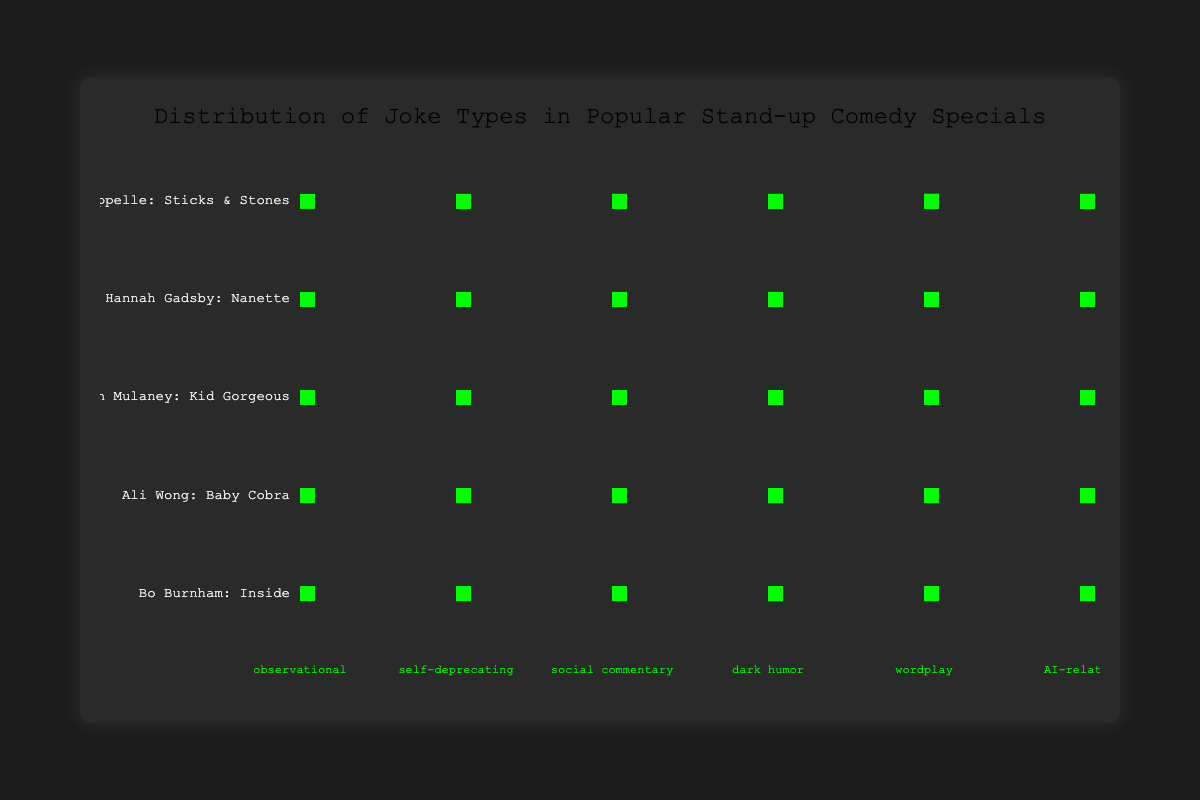What is the title of the chart? The title of the chart is usually placed at the top and in larger, more prominent text compared to other labels. In this figure, the title is "Distribution of Joke Types in Popular Stand-up Comedy Specials."
Answer: Distribution of Joke Types in Popular Stand-up Comedy Specials How many comedians' specials are represented in the chart? There are labels on the left side of the chart indicating the comedians' specials. By counting these labels, you can determine that there are 5 comedians' specials in the chart: "Dave Chappelle: Sticks & Stones," "Hannah Gadsby: Nanette," "John Mulaney: Kid Gorgeous," "Ali Wong: Baby Cobra," and "Bo Burnham: Inside."
Answer: 5 Which comedian has the most jokes categorized under observational humor? By looking at the jokes categorized under "observational" and comparing the depicted count for each comedian, you observe that "John Mulaney: Kid Gorgeous" has the most jokes in the observational humor category, as its bar is the longest.
Answer: John Mulaney: Kid Gorgeous How many total jokes are represented for "Ali Wong: Baby Cobra"? For "Ali Wong: Baby Cobra," you sum the number of jokes in each category: 30 (observational) + 20 (self-deprecating) + 25 (social commentary) + 10 (dark humor) + 10 (wordplay) + 5 (AI-related). Adding these values gives a total of 100 jokes.
Answer: 100 Which joke type is the most abundant in "Bo Burnham: Inside" special? For "Bo Burnham: Inside," you compare the number of jokes in each category. Social commentary has the highest count with 30 jokes, making it the most abundant joke type in this special.
Answer: social commentary Compare the number of social commentary jokes in "Dave Chappelle: Sticks & Stones" to those in "Hannah Gadsby: Nanette." Which is higher and by how much? "Dave Chappelle: Sticks & Stones" has 40 social commentary jokes, while "Hannah Gadsby: Nanette" has 35. Subtracting the latter from the former, 40 - 35, indicates that "Dave Chappelle: Sticks & Stones" has 5 more social commentary jokes.
Answer: Dave Chappelle: Sticks & Stones, by 5 List the comedian specials that have equal amounts of AI-related jokes. By examining the AI-related jokes for each special, you observe that "Dave Chappelle: Sticks & Stones," "Hannah Gadsby: Nanette," "John Mulaney: Kid Gorgeous," and "Ali Wong: Baby Cobra" each share the same number of AI-related jokes, which is 5.
Answer: Dave Chappelle: Sticks & Stones, Hannah Gadsby: Nanette, John Mulaney: Kid Gorgeous, Ali Wong: Baby Cobra Which joke type does "John Mulaney: Kid Gorgeous" have in the smallest proportion? Looking at "John Mulaney: Kid Gorgeous," it is evident that the smallest count for any joke type is 5, which corresponds to both dark humor and AI-related categories.
Answer: dark humor and AI-related How many more self-deprecating jokes does "Hannah Gadsby: Nanette" have compared to "Dave Chappelle: Sticks & Stones"? "Hannah Gadsby: Nanette" has 30 self-deprecating jokes, while "Dave Chappelle: Sticks & Stones" has 10. Subtracting 10 from 30 gives 20 more self-deprecating jokes in "Hannah Gadsby: Nanette."
Answer: 20 Which special has the highest count of wordplay jokes, and how many does it have? Comparing the wordplay jokes across all specials, "John Mulaney: Kid Gorgeous" and "Ali Wong: Baby Cobra" both tie with the highest number of wordplay jokes, each having 15.
Answer: John Mulaney: Kid Gorgeous and Ali Wong: Baby Cobra, 15 